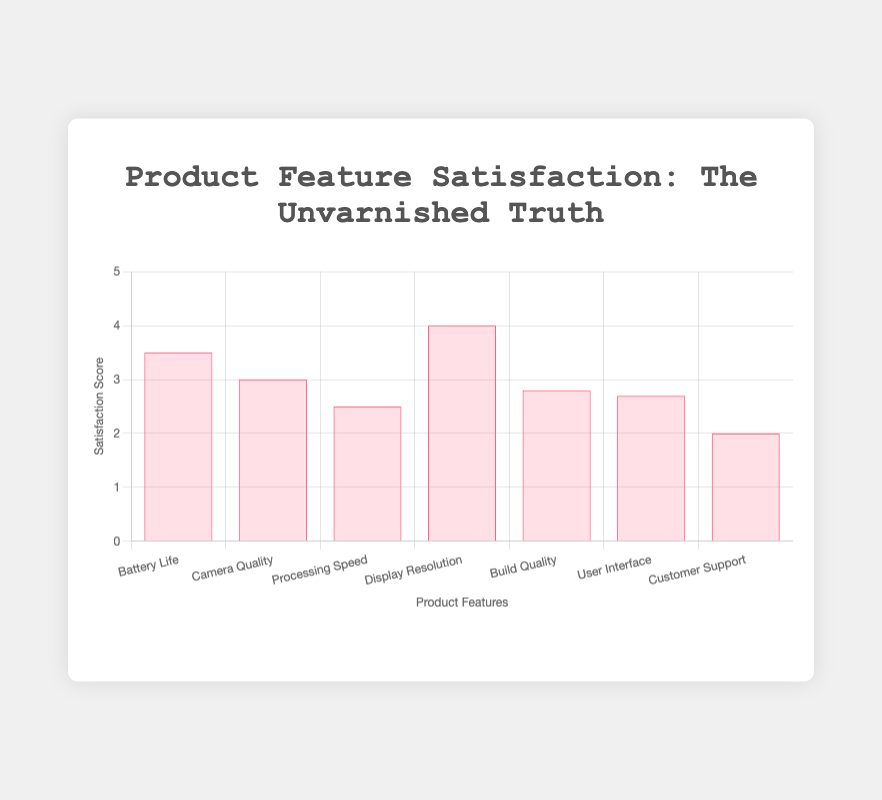What are the features rated with a satisfaction score of 2.5 or less? The features with scores of 2.5 or less are "Processing Speed" with a score of 2.5, "Build Quality" with a score of 2.8 (almost 2.5), "User Interface" with a score of 2.7 (almost 2.5), and "Customer Support" with a score of 2.0.
Answer: Processing Speed, Customer Support Which feature has the highest satisfaction score? The feature with the highest satisfaction score is "Display Resolution" with a score of 4.0.
Answer: Display Resolution What's the difference between the highest and lowest satisfaction scores? The highest satisfaction score is 4.0 (Display Resolution) and the lowest is 2.0 (Customer Support). The difference is 4.0 - 2.0 = 2.0.
Answer: 2.0 Which feature has a better satisfaction score, "Camera Quality" or "Processing Speed"? "Camera Quality" has a satisfaction score of 3.0, and "Processing Speed" has a score of 2.5. Therefore, "Camera Quality" is rated higher.
Answer: Camera Quality What is the overall average satisfaction score across all features? Sum all the satisfaction scores: 3.5 + 3.0 + 2.5 + 4.0 + 2.8 + 2.7 + 2.0 = 20.5, and divide by the number of features (7). 20.5 / 7 ≈ 2.93
Answer: 2.93 How many features have a satisfaction score that is above the average score? The average satisfaction score is 2.93. The features with scores above this average are "Battery Life" (3.5), "Camera Quality" (3.0), and "Display Resolution" (4.0).
Answer: 3 Is the satisfaction score for "Customer Support" closer to "User Interface" or "Build Quality"? "Customer Support" has a score of 2.0, "User Interface" has a score of 2.7, and "Build Quality" has a score of 2.8. The difference between "Customer Support" and "User Interface" is 2.7 - 2.0 = 0.7, and between "Customer Support" and "Build Quality" is 2.8 - 2.0 = 0.8. Therefore, "Customer Support" is closer to "User Interface".
Answer: User Interface What feature has a satisfaction score that is closest to the median score? To find the median, first order the scores: 2.0, 2.5, 2.7, 2.8, 3.0, 3.5, 4.0. The median score is 2.8. The feature with this score is "Build Quality".
Answer: Build Quality 